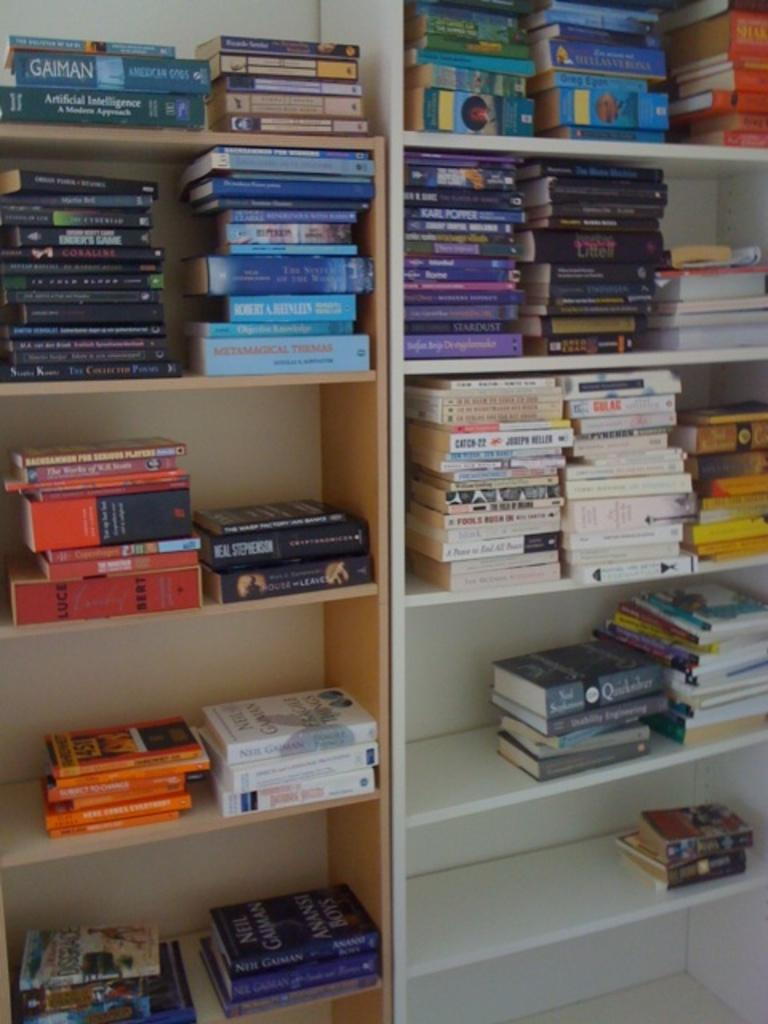What can be observed in the image that appears unusual or damaged? There are cracks in the image. What are the cracks filled with? The cracks are filled with books. What type of stem can be seen growing from the base of the books in the image? There is no stem present in the image; it features cracks filled with books. 